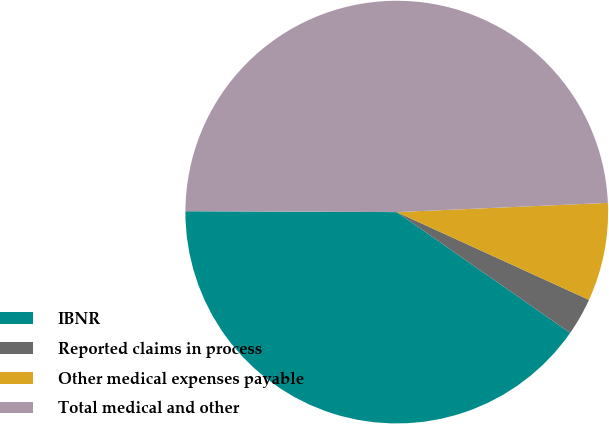<chart> <loc_0><loc_0><loc_500><loc_500><pie_chart><fcel>IBNR<fcel>Reported claims in process<fcel>Other medical expenses payable<fcel>Total medical and other<nl><fcel>40.38%<fcel>2.87%<fcel>7.51%<fcel>49.24%<nl></chart> 